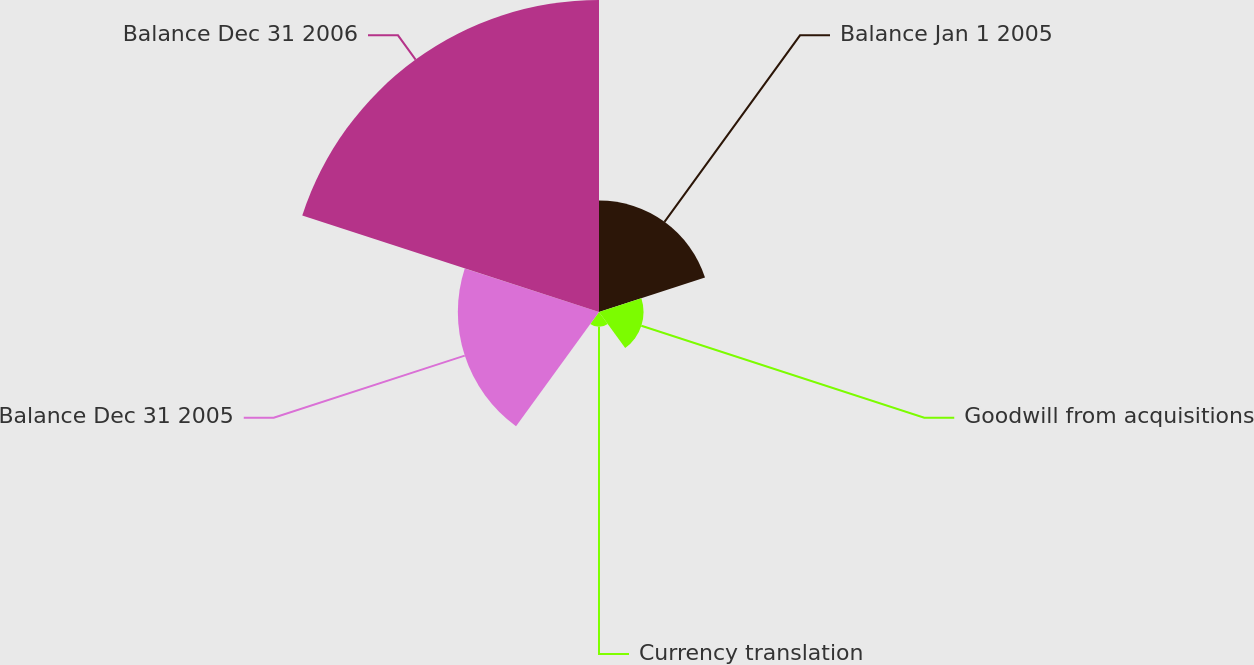Convert chart. <chart><loc_0><loc_0><loc_500><loc_500><pie_chart><fcel>Balance Jan 1 2005<fcel>Goodwill from acquisitions<fcel>Currency translation<fcel>Balance Dec 31 2005<fcel>Balance Dec 31 2006<nl><fcel>17.86%<fcel>7.14%<fcel>2.38%<fcel>22.62%<fcel>50.0%<nl></chart> 